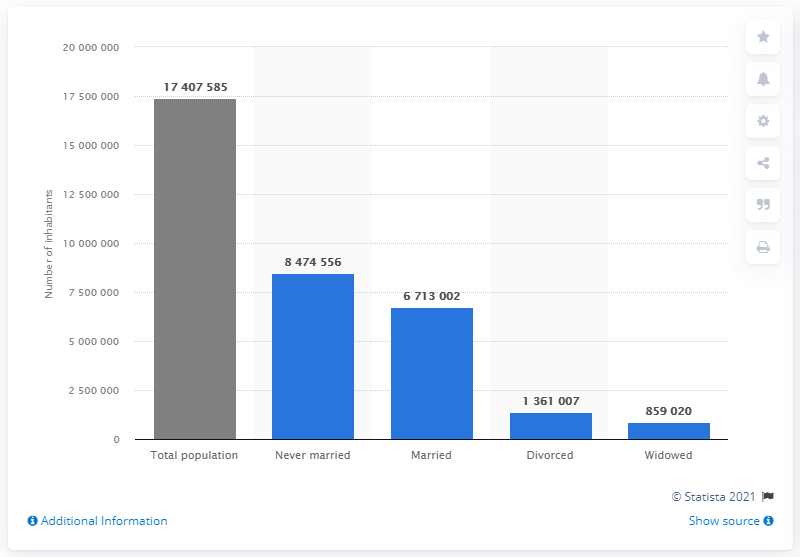Indicate a few pertinent items in this graphic. In 2020, there were approximately 1,361,007 people who were divorced in the Netherlands. In the year 2020, approximately 847,4556 people in the Netherlands had never been married. In the year 2020, there were approximately 67,130,028 married individuals living in the Netherlands. 